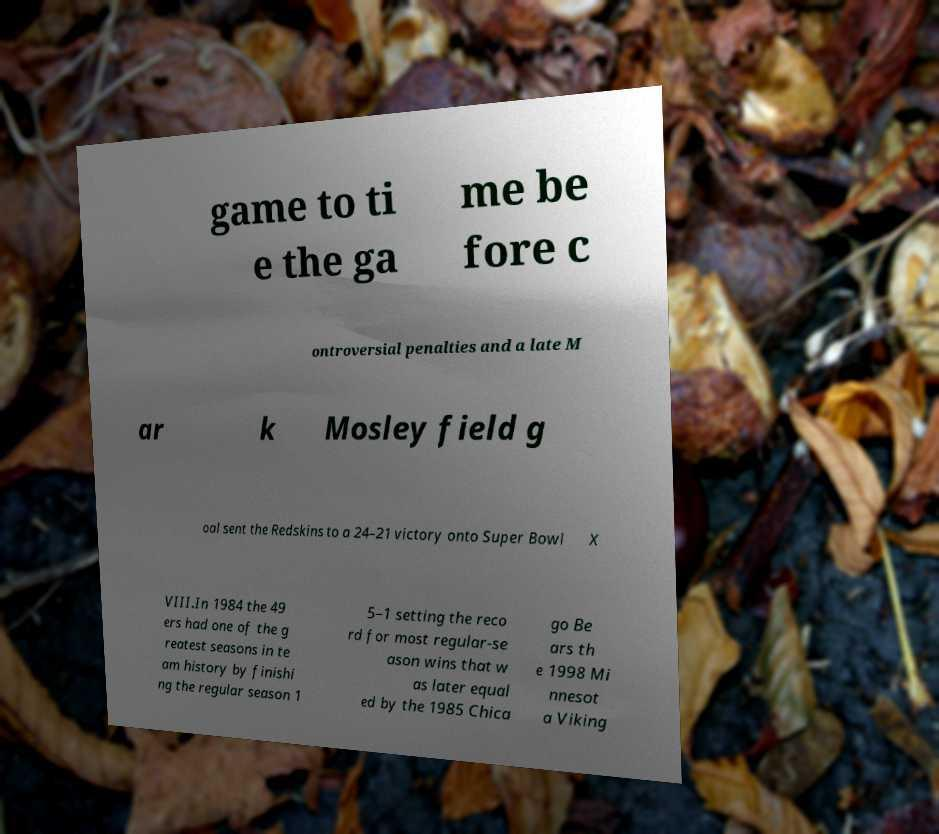Could you assist in decoding the text presented in this image and type it out clearly? game to ti e the ga me be fore c ontroversial penalties and a late M ar k Mosley field g oal sent the Redskins to a 24–21 victory onto Super Bowl X VIII.In 1984 the 49 ers had one of the g reatest seasons in te am history by finishi ng the regular season 1 5–1 setting the reco rd for most regular-se ason wins that w as later equal ed by the 1985 Chica go Be ars th e 1998 Mi nnesot a Viking 